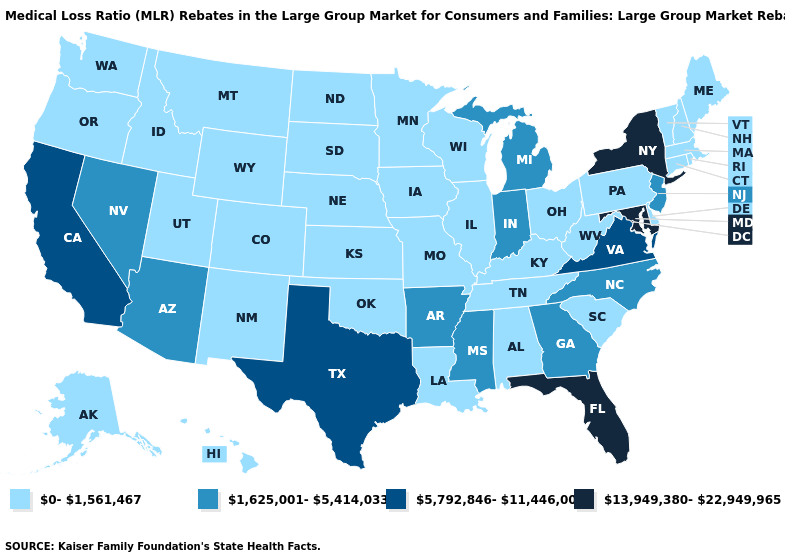Name the states that have a value in the range 0-1,561,467?
Give a very brief answer. Alabama, Alaska, Colorado, Connecticut, Delaware, Hawaii, Idaho, Illinois, Iowa, Kansas, Kentucky, Louisiana, Maine, Massachusetts, Minnesota, Missouri, Montana, Nebraska, New Hampshire, New Mexico, North Dakota, Ohio, Oklahoma, Oregon, Pennsylvania, Rhode Island, South Carolina, South Dakota, Tennessee, Utah, Vermont, Washington, West Virginia, Wisconsin, Wyoming. What is the value of Maryland?
Quick response, please. 13,949,380-22,949,965. Does Massachusetts have the same value as Georgia?
Keep it brief. No. What is the highest value in the USA?
Quick response, please. 13,949,380-22,949,965. Is the legend a continuous bar?
Write a very short answer. No. Does Pennsylvania have the lowest value in the USA?
Write a very short answer. Yes. Name the states that have a value in the range 0-1,561,467?
Give a very brief answer. Alabama, Alaska, Colorado, Connecticut, Delaware, Hawaii, Idaho, Illinois, Iowa, Kansas, Kentucky, Louisiana, Maine, Massachusetts, Minnesota, Missouri, Montana, Nebraska, New Hampshire, New Mexico, North Dakota, Ohio, Oklahoma, Oregon, Pennsylvania, Rhode Island, South Carolina, South Dakota, Tennessee, Utah, Vermont, Washington, West Virginia, Wisconsin, Wyoming. What is the lowest value in states that border Maine?
Concise answer only. 0-1,561,467. What is the value of Connecticut?
Write a very short answer. 0-1,561,467. What is the lowest value in the MidWest?
Write a very short answer. 0-1,561,467. Name the states that have a value in the range 5,792,846-11,446,002?
Give a very brief answer. California, Texas, Virginia. What is the value of Oklahoma?
Short answer required. 0-1,561,467. Among the states that border Oklahoma , does Texas have the lowest value?
Be succinct. No. Does Ohio have the same value as Colorado?
Be succinct. Yes. 